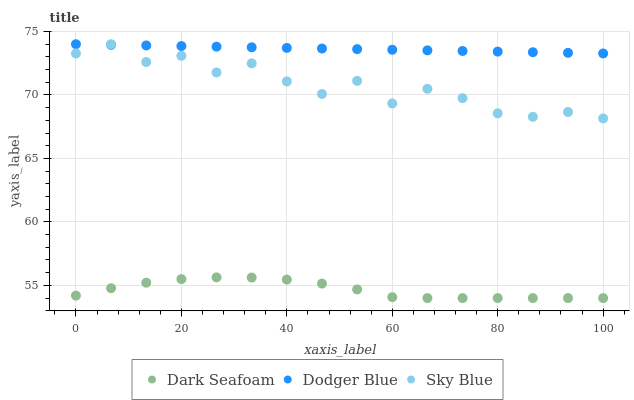Does Dark Seafoam have the minimum area under the curve?
Answer yes or no. Yes. Does Dodger Blue have the maximum area under the curve?
Answer yes or no. Yes. Does Dodger Blue have the minimum area under the curve?
Answer yes or no. No. Does Dark Seafoam have the maximum area under the curve?
Answer yes or no. No. Is Dodger Blue the smoothest?
Answer yes or no. Yes. Is Sky Blue the roughest?
Answer yes or no. Yes. Is Dark Seafoam the smoothest?
Answer yes or no. No. Is Dark Seafoam the roughest?
Answer yes or no. No. Does Dark Seafoam have the lowest value?
Answer yes or no. Yes. Does Dodger Blue have the lowest value?
Answer yes or no. No. Does Dodger Blue have the highest value?
Answer yes or no. Yes. Does Dark Seafoam have the highest value?
Answer yes or no. No. Is Dark Seafoam less than Dodger Blue?
Answer yes or no. Yes. Is Sky Blue greater than Dark Seafoam?
Answer yes or no. Yes. Does Sky Blue intersect Dodger Blue?
Answer yes or no. Yes. Is Sky Blue less than Dodger Blue?
Answer yes or no. No. Is Sky Blue greater than Dodger Blue?
Answer yes or no. No. Does Dark Seafoam intersect Dodger Blue?
Answer yes or no. No. 